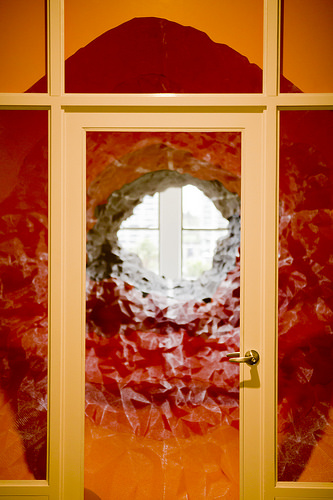<image>
Can you confirm if the frame is above the inner? Yes. The frame is positioned above the inner in the vertical space, higher up in the scene. 